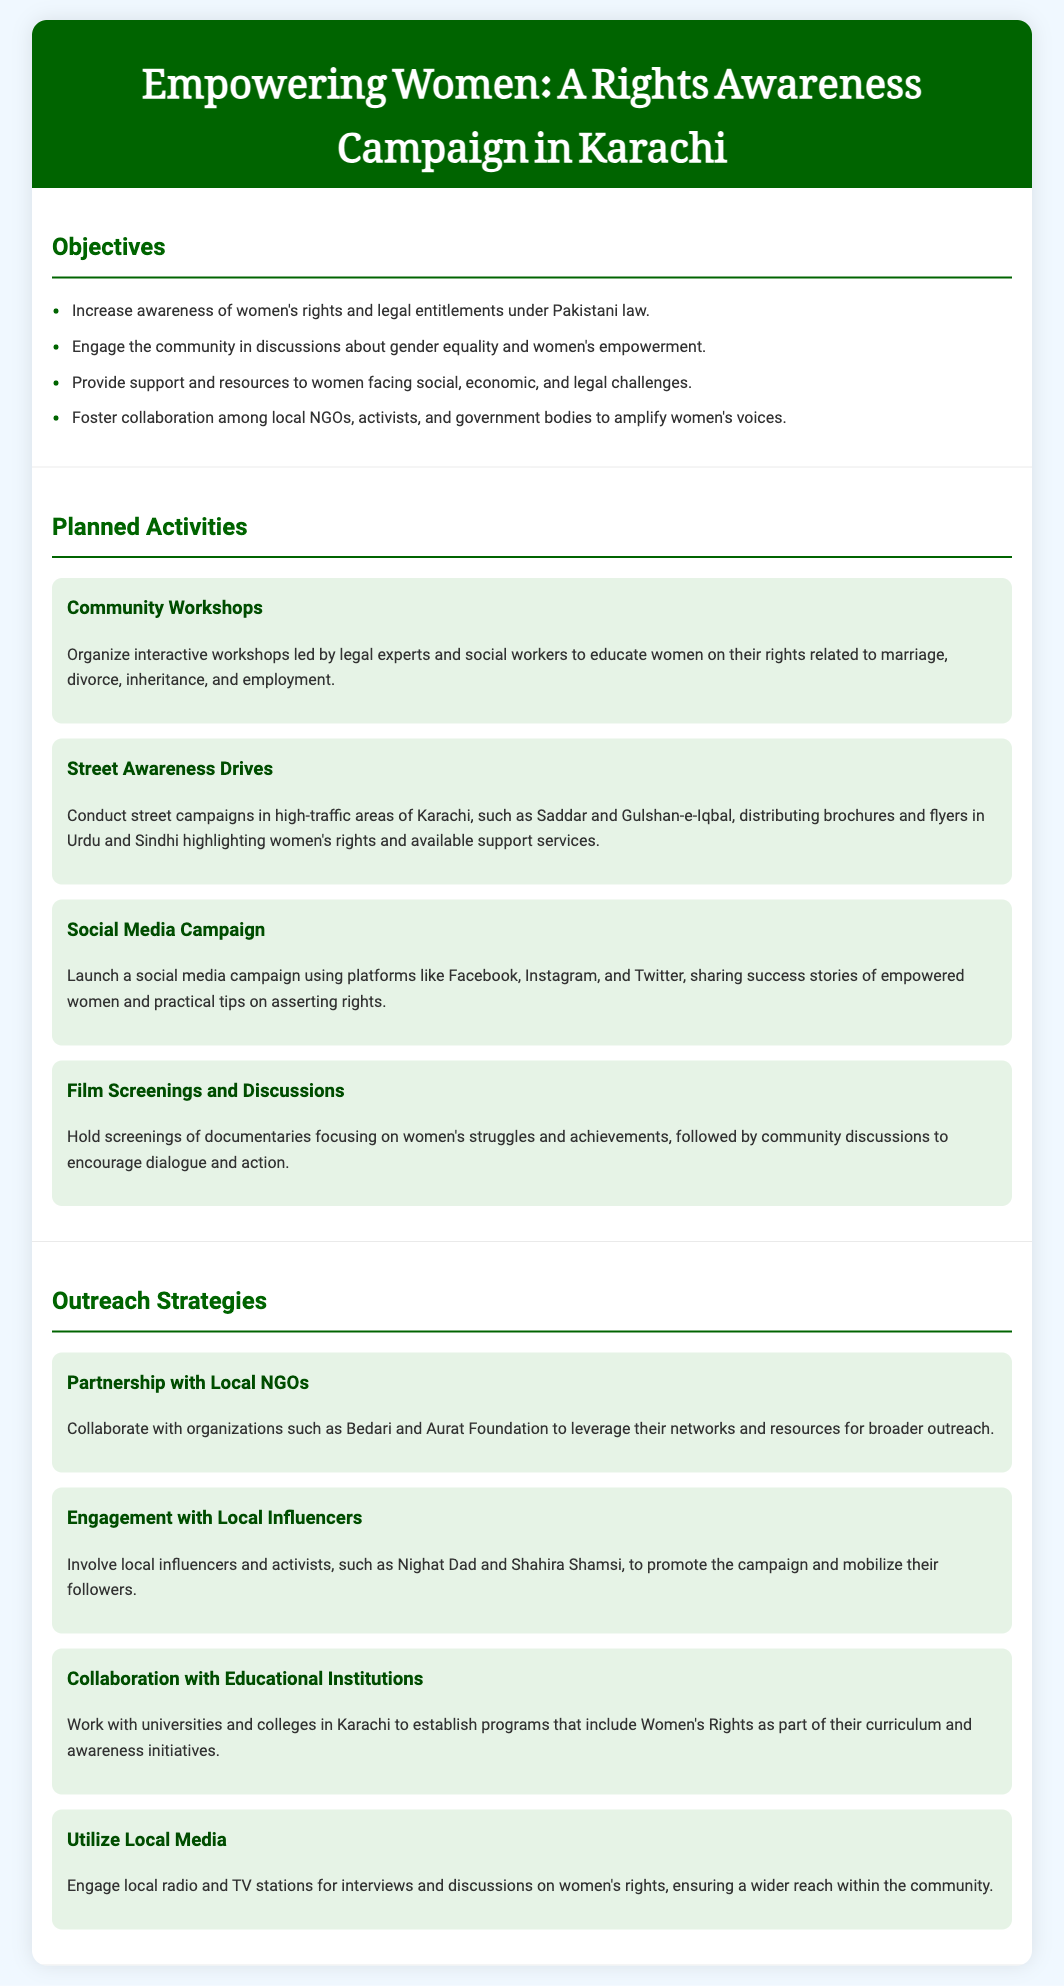what is the title of the campaign? The title of the campaign is presented in the header of the document as "Empowering Women: A Rights Awareness Campaign in Karachi."
Answer: Empowering Women: A Rights Awareness Campaign in Karachi how many objectives are listed in the document? The document outlines a total of four objectives under the "Objectives" section.
Answer: 4 who are the organizations mentioned for collaboration? The document mentions local NGOs such as Bedari and Aurat Foundation for collaboration in outreach strategies.
Answer: Bedari, Aurat Foundation what is one planned activity of the campaign? The document includes several planned activities; one mentioned is "Community Workshops."
Answer: Community Workshops which platforms will be used for the social media campaign? The social media campaign will utilize platforms like Facebook, Instagram, and Twitter as per the activities outlined in the document.
Answer: Facebook, Instagram, Twitter who is mentioned as a local influencer in the outreach strategies? The document references Nighat Dad as a local influencer to promote the campaign.
Answer: Nighat Dad what type of activities will follow film screenings? The document states that community discussions will follow the film screenings of documentaries focusing on women's struggles and achievements.
Answer: Community discussions which sections are included in the document? The document includes the sections "Objectives," "Planned Activities," and "Outreach Strategies."
Answer: Objectives, Planned Activities, Outreach Strategies 